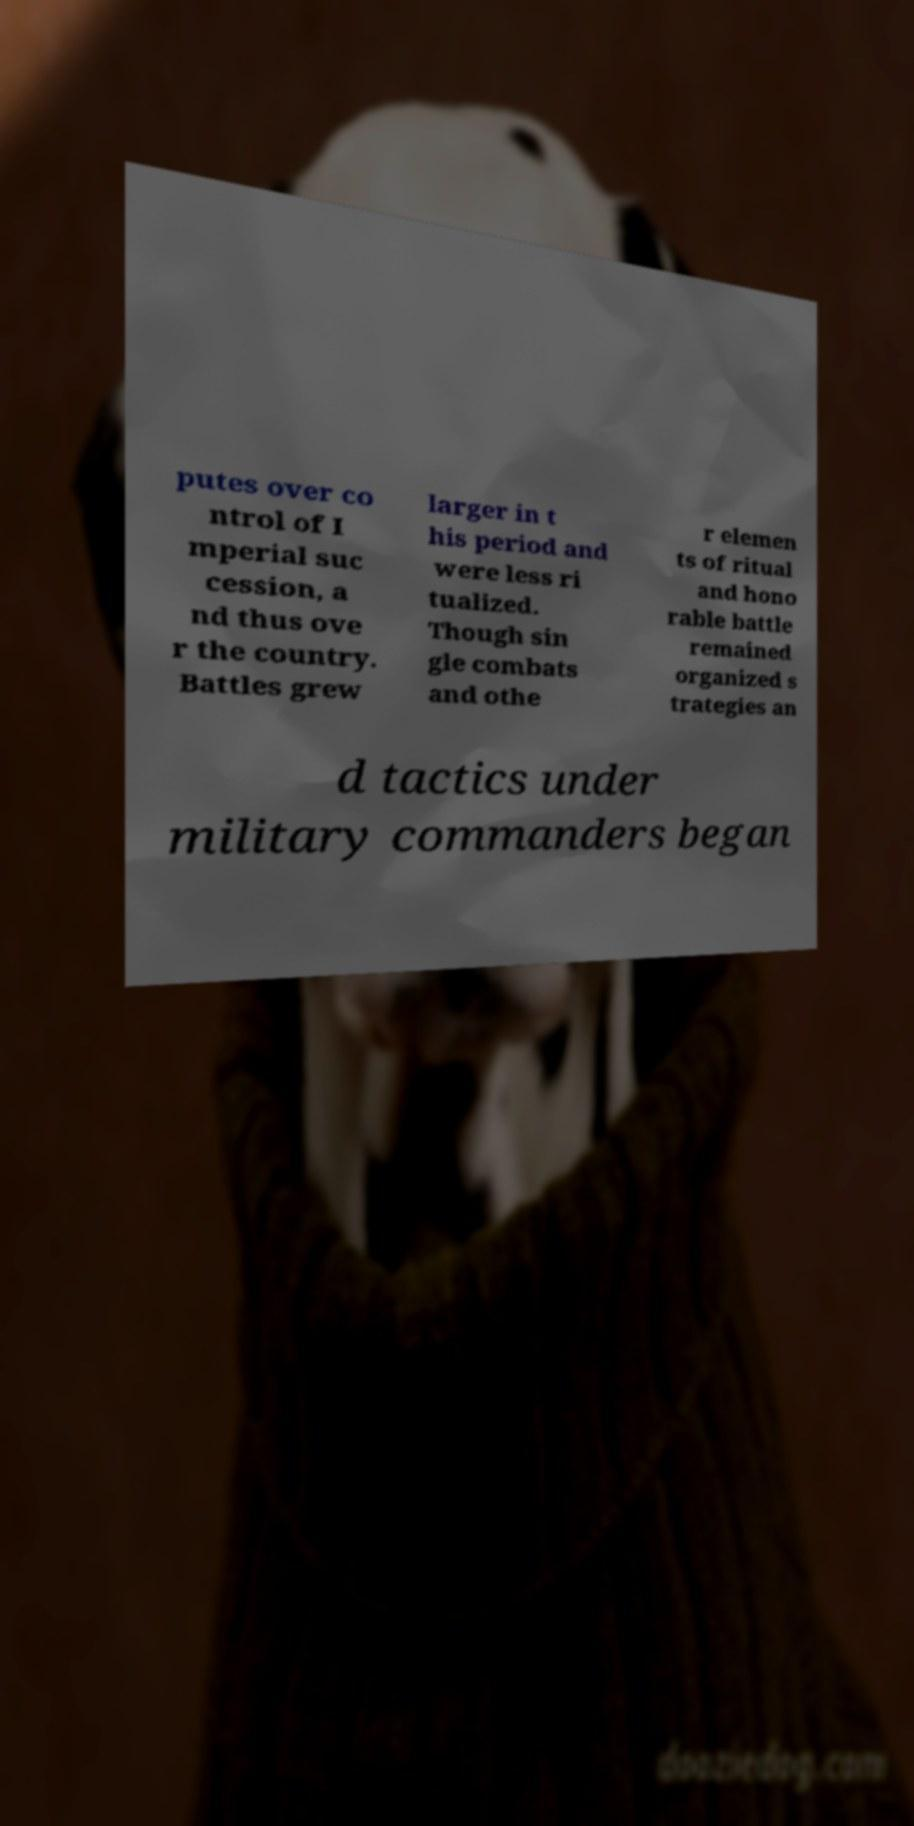I need the written content from this picture converted into text. Can you do that? putes over co ntrol of I mperial suc cession, a nd thus ove r the country. Battles grew larger in t his period and were less ri tualized. Though sin gle combats and othe r elemen ts of ritual and hono rable battle remained organized s trategies an d tactics under military commanders began 